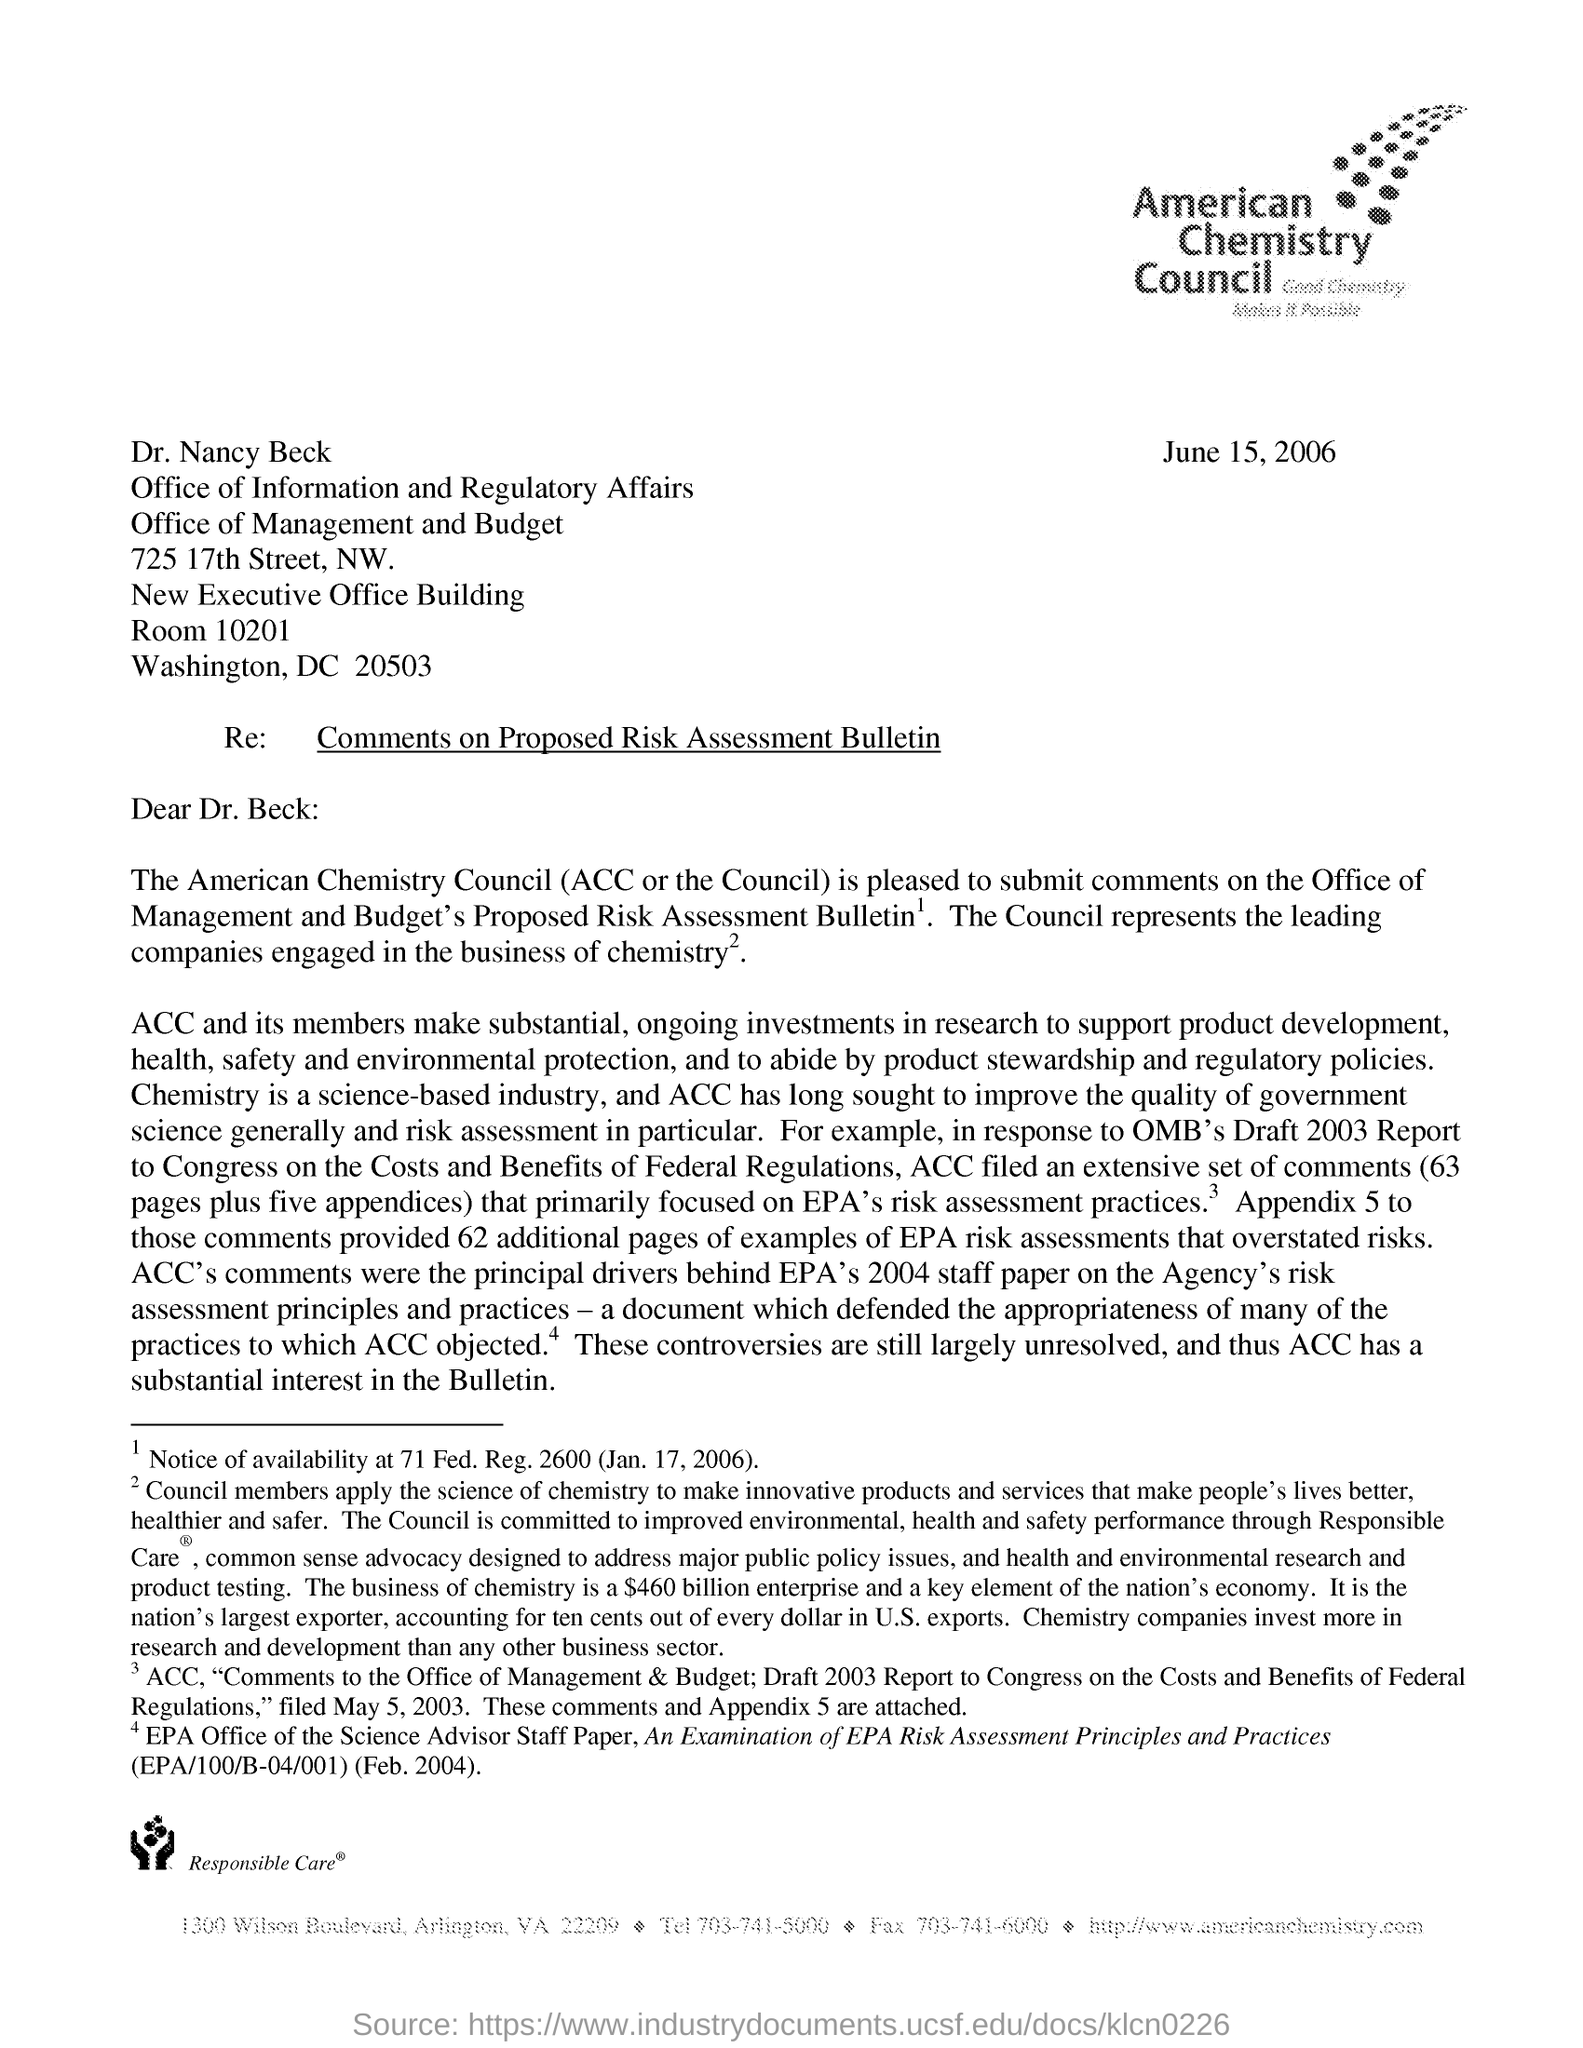What is the issued date of this letter?
Make the answer very short. June 15, 2006. What is the subject of the letter?
Your response must be concise. Comments on proposed risk assessment bulletin. What is ACC stands for?
Your answer should be very brief. American Chemistry Council. 